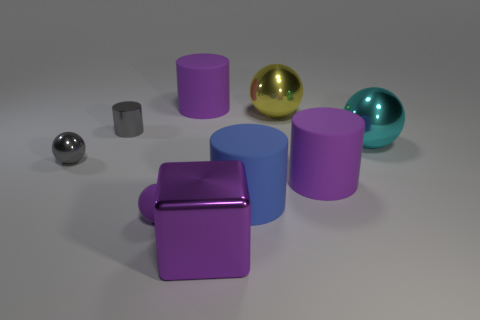Is there a metallic object to the right of the shiny sphere that is left of the purple rubber object that is behind the cyan shiny thing?
Your answer should be compact. Yes. The yellow metallic thing is what shape?
Provide a succinct answer. Sphere. Does the big ball behind the small metal cylinder have the same material as the large object that is in front of the tiny rubber sphere?
Keep it short and to the point. Yes. How many cylinders have the same color as the rubber sphere?
Keep it short and to the point. 2. What shape is the metal object that is behind the cyan object and to the right of the gray cylinder?
Provide a short and direct response. Sphere. There is a thing that is both on the left side of the large cube and in front of the tiny gray ball; what color is it?
Ensure brevity in your answer.  Purple. Are there more tiny gray metal balls that are on the right side of the large cyan metal ball than small purple balls that are on the left side of the gray metallic cylinder?
Provide a short and direct response. No. What color is the large shiny ball behind the large cyan object?
Your answer should be very brief. Yellow. Is the shape of the large purple rubber object that is to the right of the cube the same as the big matte object behind the big cyan thing?
Your answer should be very brief. Yes. Is there a object of the same size as the yellow metal sphere?
Offer a very short reply. Yes. 